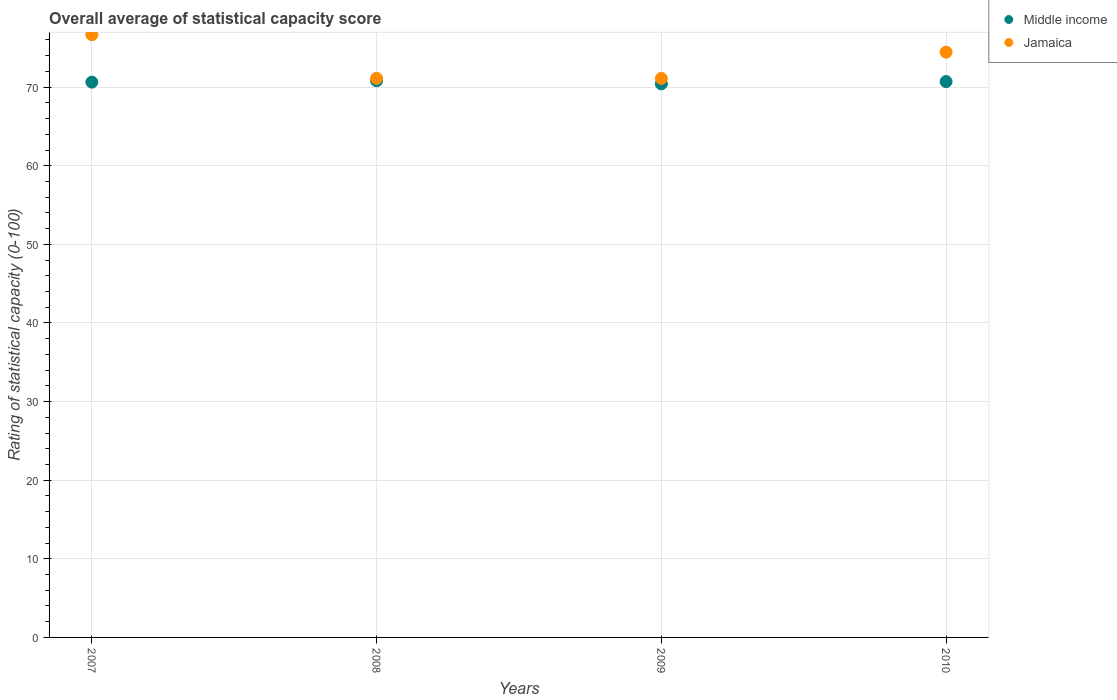How many different coloured dotlines are there?
Ensure brevity in your answer.  2. Is the number of dotlines equal to the number of legend labels?
Your response must be concise. Yes. What is the rating of statistical capacity in Middle income in 2007?
Offer a terse response. 70.63. Across all years, what is the maximum rating of statistical capacity in Middle income?
Keep it short and to the point. 70.81. Across all years, what is the minimum rating of statistical capacity in Jamaica?
Offer a terse response. 71.11. In which year was the rating of statistical capacity in Jamaica maximum?
Provide a succinct answer. 2007. In which year was the rating of statistical capacity in Jamaica minimum?
Your response must be concise. 2008. What is the total rating of statistical capacity in Middle income in the graph?
Offer a terse response. 282.56. What is the difference between the rating of statistical capacity in Middle income in 2007 and that in 2008?
Make the answer very short. -0.17. What is the difference between the rating of statistical capacity in Jamaica in 2010 and the rating of statistical capacity in Middle income in 2008?
Your response must be concise. 3.64. What is the average rating of statistical capacity in Middle income per year?
Provide a succinct answer. 70.64. In the year 2010, what is the difference between the rating of statistical capacity in Middle income and rating of statistical capacity in Jamaica?
Provide a short and direct response. -3.74. In how many years, is the rating of statistical capacity in Middle income greater than 36?
Keep it short and to the point. 4. What is the ratio of the rating of statistical capacity in Middle income in 2007 to that in 2008?
Your answer should be compact. 1. Is the difference between the rating of statistical capacity in Middle income in 2009 and 2010 greater than the difference between the rating of statistical capacity in Jamaica in 2009 and 2010?
Provide a succinct answer. Yes. What is the difference between the highest and the second highest rating of statistical capacity in Jamaica?
Ensure brevity in your answer.  2.22. What is the difference between the highest and the lowest rating of statistical capacity in Jamaica?
Your answer should be very brief. 5.56. In how many years, is the rating of statistical capacity in Jamaica greater than the average rating of statistical capacity in Jamaica taken over all years?
Keep it short and to the point. 2. Is the rating of statistical capacity in Middle income strictly greater than the rating of statistical capacity in Jamaica over the years?
Provide a succinct answer. No. How many dotlines are there?
Make the answer very short. 2. What is the difference between two consecutive major ticks on the Y-axis?
Your response must be concise. 10. Does the graph contain any zero values?
Your answer should be compact. No. Does the graph contain grids?
Your answer should be very brief. Yes. Where does the legend appear in the graph?
Your response must be concise. Top right. How many legend labels are there?
Offer a terse response. 2. What is the title of the graph?
Your response must be concise. Overall average of statistical capacity score. What is the label or title of the X-axis?
Ensure brevity in your answer.  Years. What is the label or title of the Y-axis?
Offer a terse response. Rating of statistical capacity (0-100). What is the Rating of statistical capacity (0-100) in Middle income in 2007?
Ensure brevity in your answer.  70.63. What is the Rating of statistical capacity (0-100) in Jamaica in 2007?
Ensure brevity in your answer.  76.67. What is the Rating of statistical capacity (0-100) of Middle income in 2008?
Offer a very short reply. 70.81. What is the Rating of statistical capacity (0-100) in Jamaica in 2008?
Provide a succinct answer. 71.11. What is the Rating of statistical capacity (0-100) in Middle income in 2009?
Provide a succinct answer. 70.41. What is the Rating of statistical capacity (0-100) in Jamaica in 2009?
Offer a terse response. 71.11. What is the Rating of statistical capacity (0-100) of Middle income in 2010?
Make the answer very short. 70.71. What is the Rating of statistical capacity (0-100) of Jamaica in 2010?
Your answer should be compact. 74.44. Across all years, what is the maximum Rating of statistical capacity (0-100) of Middle income?
Your answer should be very brief. 70.81. Across all years, what is the maximum Rating of statistical capacity (0-100) in Jamaica?
Keep it short and to the point. 76.67. Across all years, what is the minimum Rating of statistical capacity (0-100) in Middle income?
Ensure brevity in your answer.  70.41. Across all years, what is the minimum Rating of statistical capacity (0-100) in Jamaica?
Offer a very short reply. 71.11. What is the total Rating of statistical capacity (0-100) in Middle income in the graph?
Keep it short and to the point. 282.56. What is the total Rating of statistical capacity (0-100) in Jamaica in the graph?
Offer a terse response. 293.33. What is the difference between the Rating of statistical capacity (0-100) of Middle income in 2007 and that in 2008?
Make the answer very short. -0.17. What is the difference between the Rating of statistical capacity (0-100) of Jamaica in 2007 and that in 2008?
Provide a succinct answer. 5.56. What is the difference between the Rating of statistical capacity (0-100) of Middle income in 2007 and that in 2009?
Provide a short and direct response. 0.22. What is the difference between the Rating of statistical capacity (0-100) of Jamaica in 2007 and that in 2009?
Give a very brief answer. 5.56. What is the difference between the Rating of statistical capacity (0-100) in Middle income in 2007 and that in 2010?
Ensure brevity in your answer.  -0.07. What is the difference between the Rating of statistical capacity (0-100) of Jamaica in 2007 and that in 2010?
Offer a terse response. 2.22. What is the difference between the Rating of statistical capacity (0-100) of Middle income in 2008 and that in 2009?
Your response must be concise. 0.4. What is the difference between the Rating of statistical capacity (0-100) of Middle income in 2008 and that in 2010?
Your response must be concise. 0.1. What is the difference between the Rating of statistical capacity (0-100) in Jamaica in 2008 and that in 2010?
Give a very brief answer. -3.33. What is the difference between the Rating of statistical capacity (0-100) of Middle income in 2009 and that in 2010?
Provide a succinct answer. -0.29. What is the difference between the Rating of statistical capacity (0-100) of Jamaica in 2009 and that in 2010?
Keep it short and to the point. -3.33. What is the difference between the Rating of statistical capacity (0-100) of Middle income in 2007 and the Rating of statistical capacity (0-100) of Jamaica in 2008?
Your answer should be compact. -0.48. What is the difference between the Rating of statistical capacity (0-100) of Middle income in 2007 and the Rating of statistical capacity (0-100) of Jamaica in 2009?
Offer a terse response. -0.48. What is the difference between the Rating of statistical capacity (0-100) in Middle income in 2007 and the Rating of statistical capacity (0-100) in Jamaica in 2010?
Offer a very short reply. -3.81. What is the difference between the Rating of statistical capacity (0-100) of Middle income in 2008 and the Rating of statistical capacity (0-100) of Jamaica in 2009?
Provide a short and direct response. -0.3. What is the difference between the Rating of statistical capacity (0-100) in Middle income in 2008 and the Rating of statistical capacity (0-100) in Jamaica in 2010?
Give a very brief answer. -3.64. What is the difference between the Rating of statistical capacity (0-100) of Middle income in 2009 and the Rating of statistical capacity (0-100) of Jamaica in 2010?
Offer a very short reply. -4.03. What is the average Rating of statistical capacity (0-100) in Middle income per year?
Give a very brief answer. 70.64. What is the average Rating of statistical capacity (0-100) in Jamaica per year?
Give a very brief answer. 73.33. In the year 2007, what is the difference between the Rating of statistical capacity (0-100) in Middle income and Rating of statistical capacity (0-100) in Jamaica?
Provide a short and direct response. -6.03. In the year 2008, what is the difference between the Rating of statistical capacity (0-100) of Middle income and Rating of statistical capacity (0-100) of Jamaica?
Ensure brevity in your answer.  -0.3. In the year 2009, what is the difference between the Rating of statistical capacity (0-100) in Middle income and Rating of statistical capacity (0-100) in Jamaica?
Give a very brief answer. -0.7. In the year 2010, what is the difference between the Rating of statistical capacity (0-100) of Middle income and Rating of statistical capacity (0-100) of Jamaica?
Give a very brief answer. -3.74. What is the ratio of the Rating of statistical capacity (0-100) in Jamaica in 2007 to that in 2008?
Ensure brevity in your answer.  1.08. What is the ratio of the Rating of statistical capacity (0-100) of Jamaica in 2007 to that in 2009?
Provide a succinct answer. 1.08. What is the ratio of the Rating of statistical capacity (0-100) in Jamaica in 2007 to that in 2010?
Your answer should be very brief. 1.03. What is the ratio of the Rating of statistical capacity (0-100) of Middle income in 2008 to that in 2009?
Offer a very short reply. 1.01. What is the ratio of the Rating of statistical capacity (0-100) in Jamaica in 2008 to that in 2010?
Provide a succinct answer. 0.96. What is the ratio of the Rating of statistical capacity (0-100) of Jamaica in 2009 to that in 2010?
Make the answer very short. 0.96. What is the difference between the highest and the second highest Rating of statistical capacity (0-100) of Middle income?
Keep it short and to the point. 0.1. What is the difference between the highest and the second highest Rating of statistical capacity (0-100) of Jamaica?
Make the answer very short. 2.22. What is the difference between the highest and the lowest Rating of statistical capacity (0-100) of Middle income?
Your answer should be very brief. 0.4. What is the difference between the highest and the lowest Rating of statistical capacity (0-100) in Jamaica?
Make the answer very short. 5.56. 